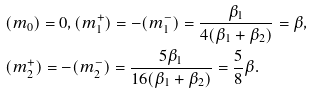Convert formula to latex. <formula><loc_0><loc_0><loc_500><loc_500>& ( m _ { 0 } ) = 0 , ( m _ { 1 } ^ { + } ) = - ( m _ { 1 } ^ { - } ) = \frac { \beta _ { 1 } } { 4 ( \beta _ { 1 } + \beta _ { 2 } ) } = \beta , \\ & ( m _ { 2 } ^ { + } ) = - ( m _ { 2 } ^ { - } ) = \frac { 5 \beta _ { 1 } } { 1 6 ( \beta _ { 1 } + \beta _ { 2 } ) } = \frac { 5 } { 8 } \beta .</formula> 